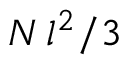<formula> <loc_0><loc_0><loc_500><loc_500>N \, l ^ { 2 } / 3</formula> 